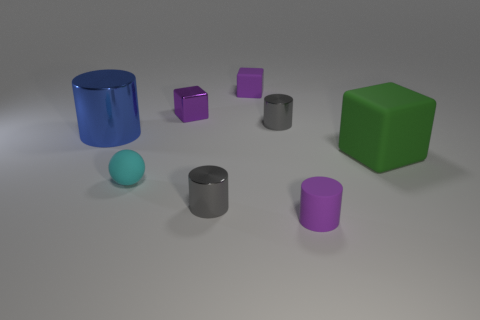Subtract 1 cylinders. How many cylinders are left? 3 Add 1 small purple metallic cubes. How many objects exist? 9 Subtract all blocks. How many objects are left? 5 Subtract all tiny rubber balls. Subtract all large green matte blocks. How many objects are left? 6 Add 1 matte spheres. How many matte spheres are left? 2 Add 8 yellow spheres. How many yellow spheres exist? 8 Subtract 1 green blocks. How many objects are left? 7 